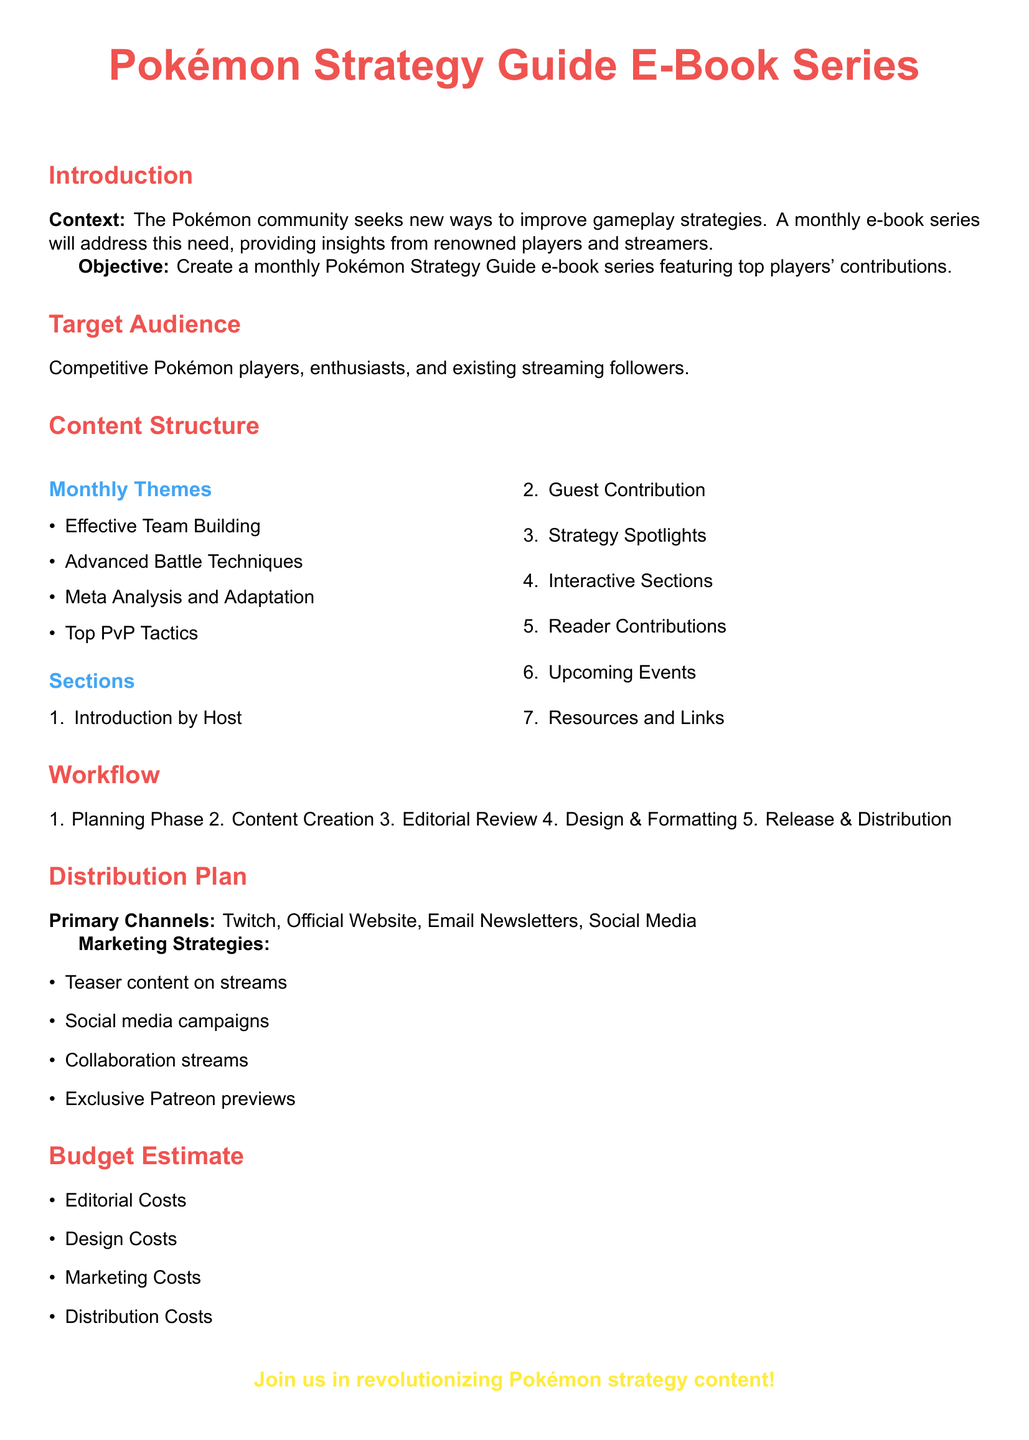What is the title of the proposal? The title is the main heading of the document, presented prominently at the top.
Answer: Pokémon Strategy Guide E-Book Series What is the primary objective of the proposal? The objective outlines the goal of the e-book series as stated in the document.
Answer: Create a monthly Pokémon Strategy Guide e-book series featuring top players' contributions Who is the target audience for the e-book series? The target audience specifies who the content is aimed at, as outlined in the document.
Answer: Competitive Pokémon players, enthusiasts, and existing streaming followers How many sections are listed under the content structure? The number of sections is explicitly stated in the enumerated list in the content structure.
Answer: 7 What are the primary distribution channels mentioned? The distribution plan details where the e-books will be distributed primarily as per the document.
Answer: Twitch, Official Website, Email Newsletters, Social Media What is one of the marketing strategies proposed? The marketing strategies are listed in the document, indicating how the e-books will be promoted.
Answer: Teaser content on streams What is the first phase of the workflow? The workflow outlines the steps to be followed in the project, with each step listed in order.
Answer: Planning Phase What are two of the monthly themes included in the e-book series? The monthly themes are listed under a bullet point section in the content structure.
Answer: Effective Team Building, Advanced Battle Techniques What color is used for section titles in the document? The document specifies the color theme for section titles through predefined color definitions.
Answer: Pokemon Red How is reader engagement incorporated into the e-book? The document lists "Reader Contributions" as a section, indicating engagement with the audience.
Answer: Interactive Sections 